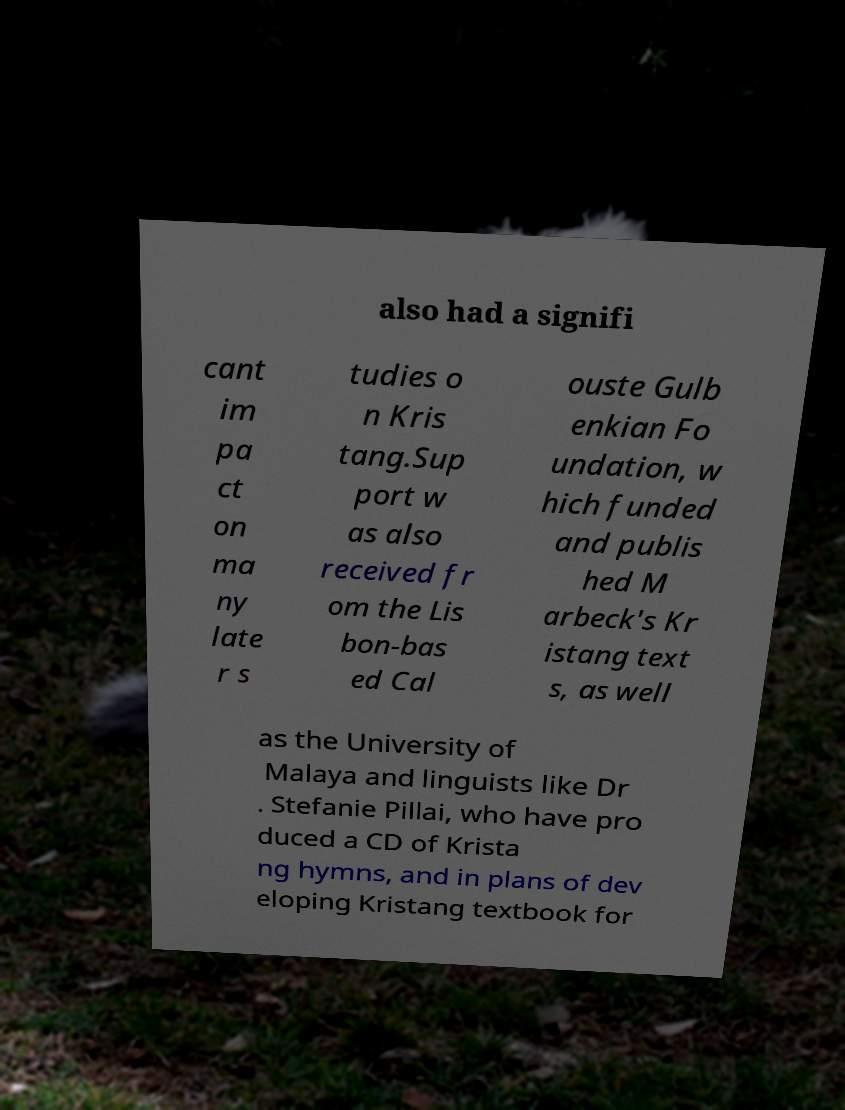Could you assist in decoding the text presented in this image and type it out clearly? also had a signifi cant im pa ct on ma ny late r s tudies o n Kris tang.Sup port w as also received fr om the Lis bon-bas ed Cal ouste Gulb enkian Fo undation, w hich funded and publis hed M arbeck's Kr istang text s, as well as the University of Malaya and linguists like Dr . Stefanie Pillai, who have pro duced a CD of Krista ng hymns, and in plans of dev eloping Kristang textbook for 